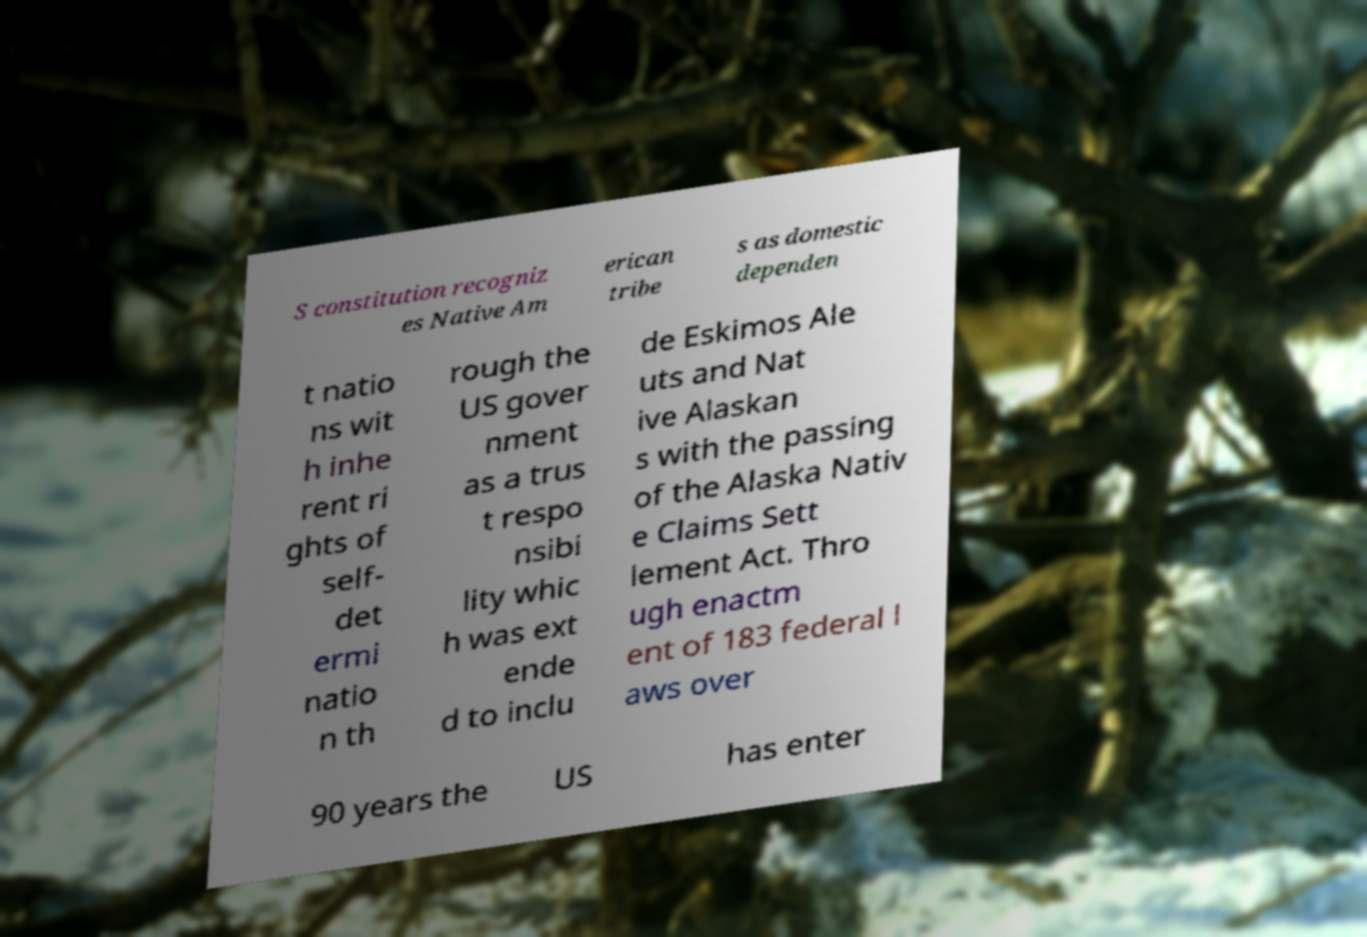Can you read and provide the text displayed in the image?This photo seems to have some interesting text. Can you extract and type it out for me? S constitution recogniz es Native Am erican tribe s as domestic dependen t natio ns wit h inhe rent ri ghts of self- det ermi natio n th rough the US gover nment as a trus t respo nsibi lity whic h was ext ende d to inclu de Eskimos Ale uts and Nat ive Alaskan s with the passing of the Alaska Nativ e Claims Sett lement Act. Thro ugh enactm ent of 183 federal l aws over 90 years the US has enter 